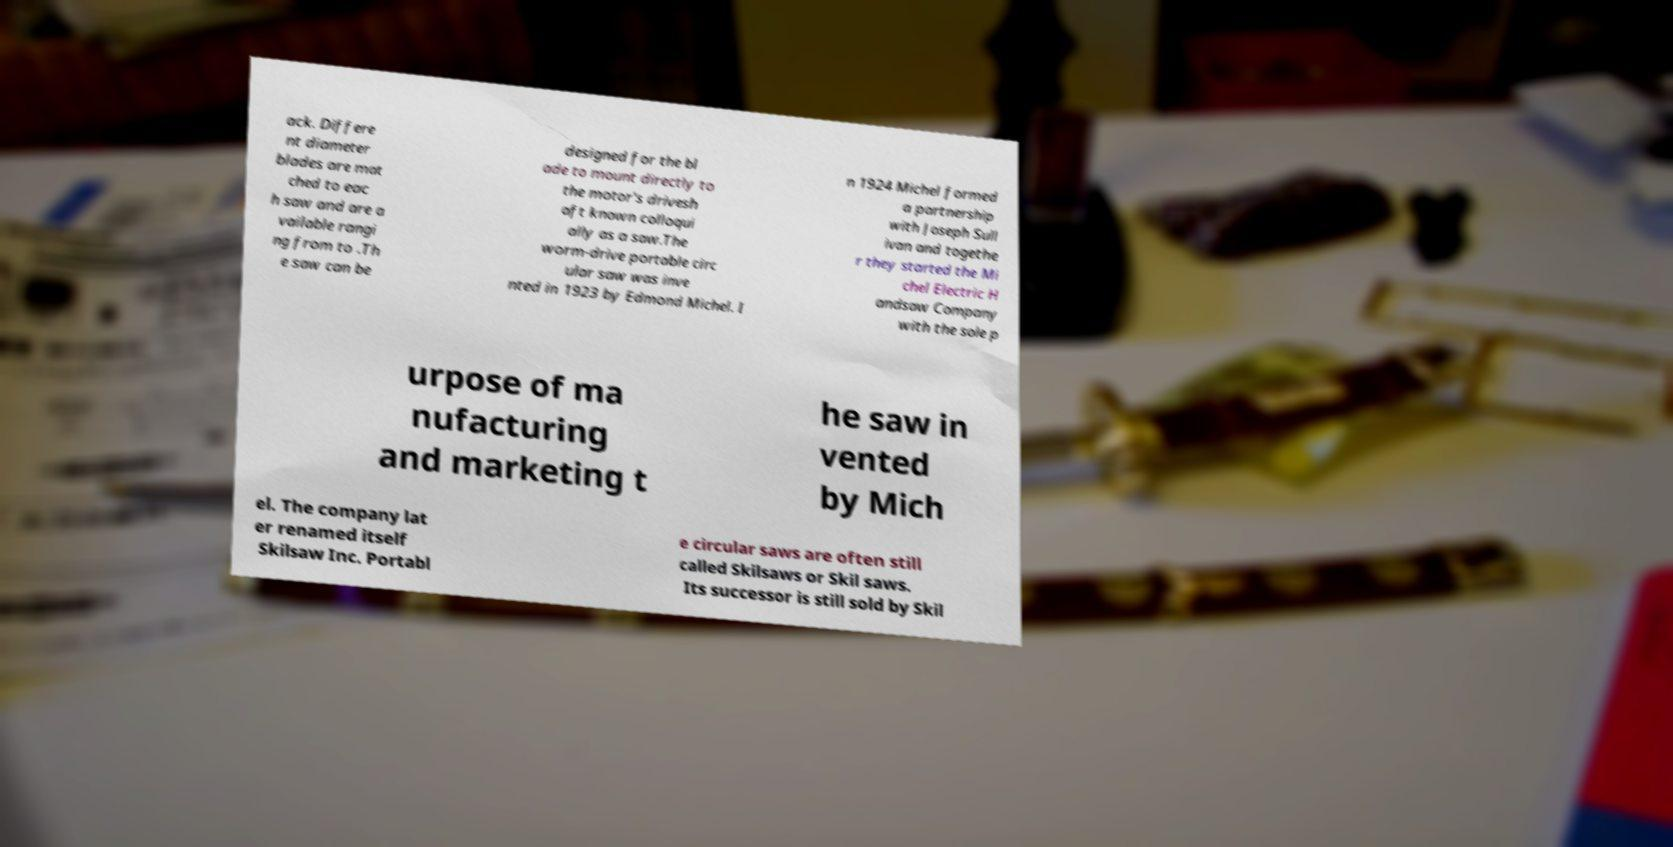I need the written content from this picture converted into text. Can you do that? ack. Differe nt diameter blades are mat ched to eac h saw and are a vailable rangi ng from to .Th e saw can be designed for the bl ade to mount directly to the motor's drivesh aft known colloqui ally as a saw.The worm-drive portable circ ular saw was inve nted in 1923 by Edmond Michel. I n 1924 Michel formed a partnership with Joseph Sull ivan and togethe r they started the Mi chel Electric H andsaw Company with the sole p urpose of ma nufacturing and marketing t he saw in vented by Mich el. The company lat er renamed itself Skilsaw Inc. Portabl e circular saws are often still called Skilsaws or Skil saws. Its successor is still sold by Skil 